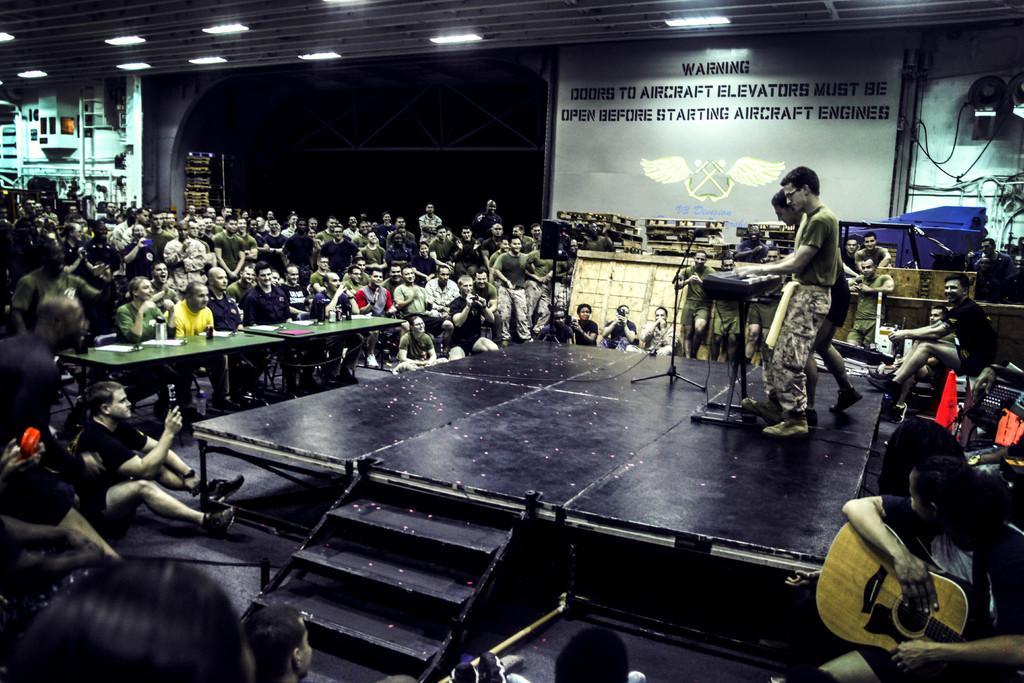In one or two sentences, can you explain what this image depicts? In this picture there is a stage in the center of the image and there are two boys, those who are playing piano on the stage, there is a mic in front of him and there are people those who are sitting around the stage, there are lamps on the roof at the top side of the image and there is a screen in the background area of the image. 